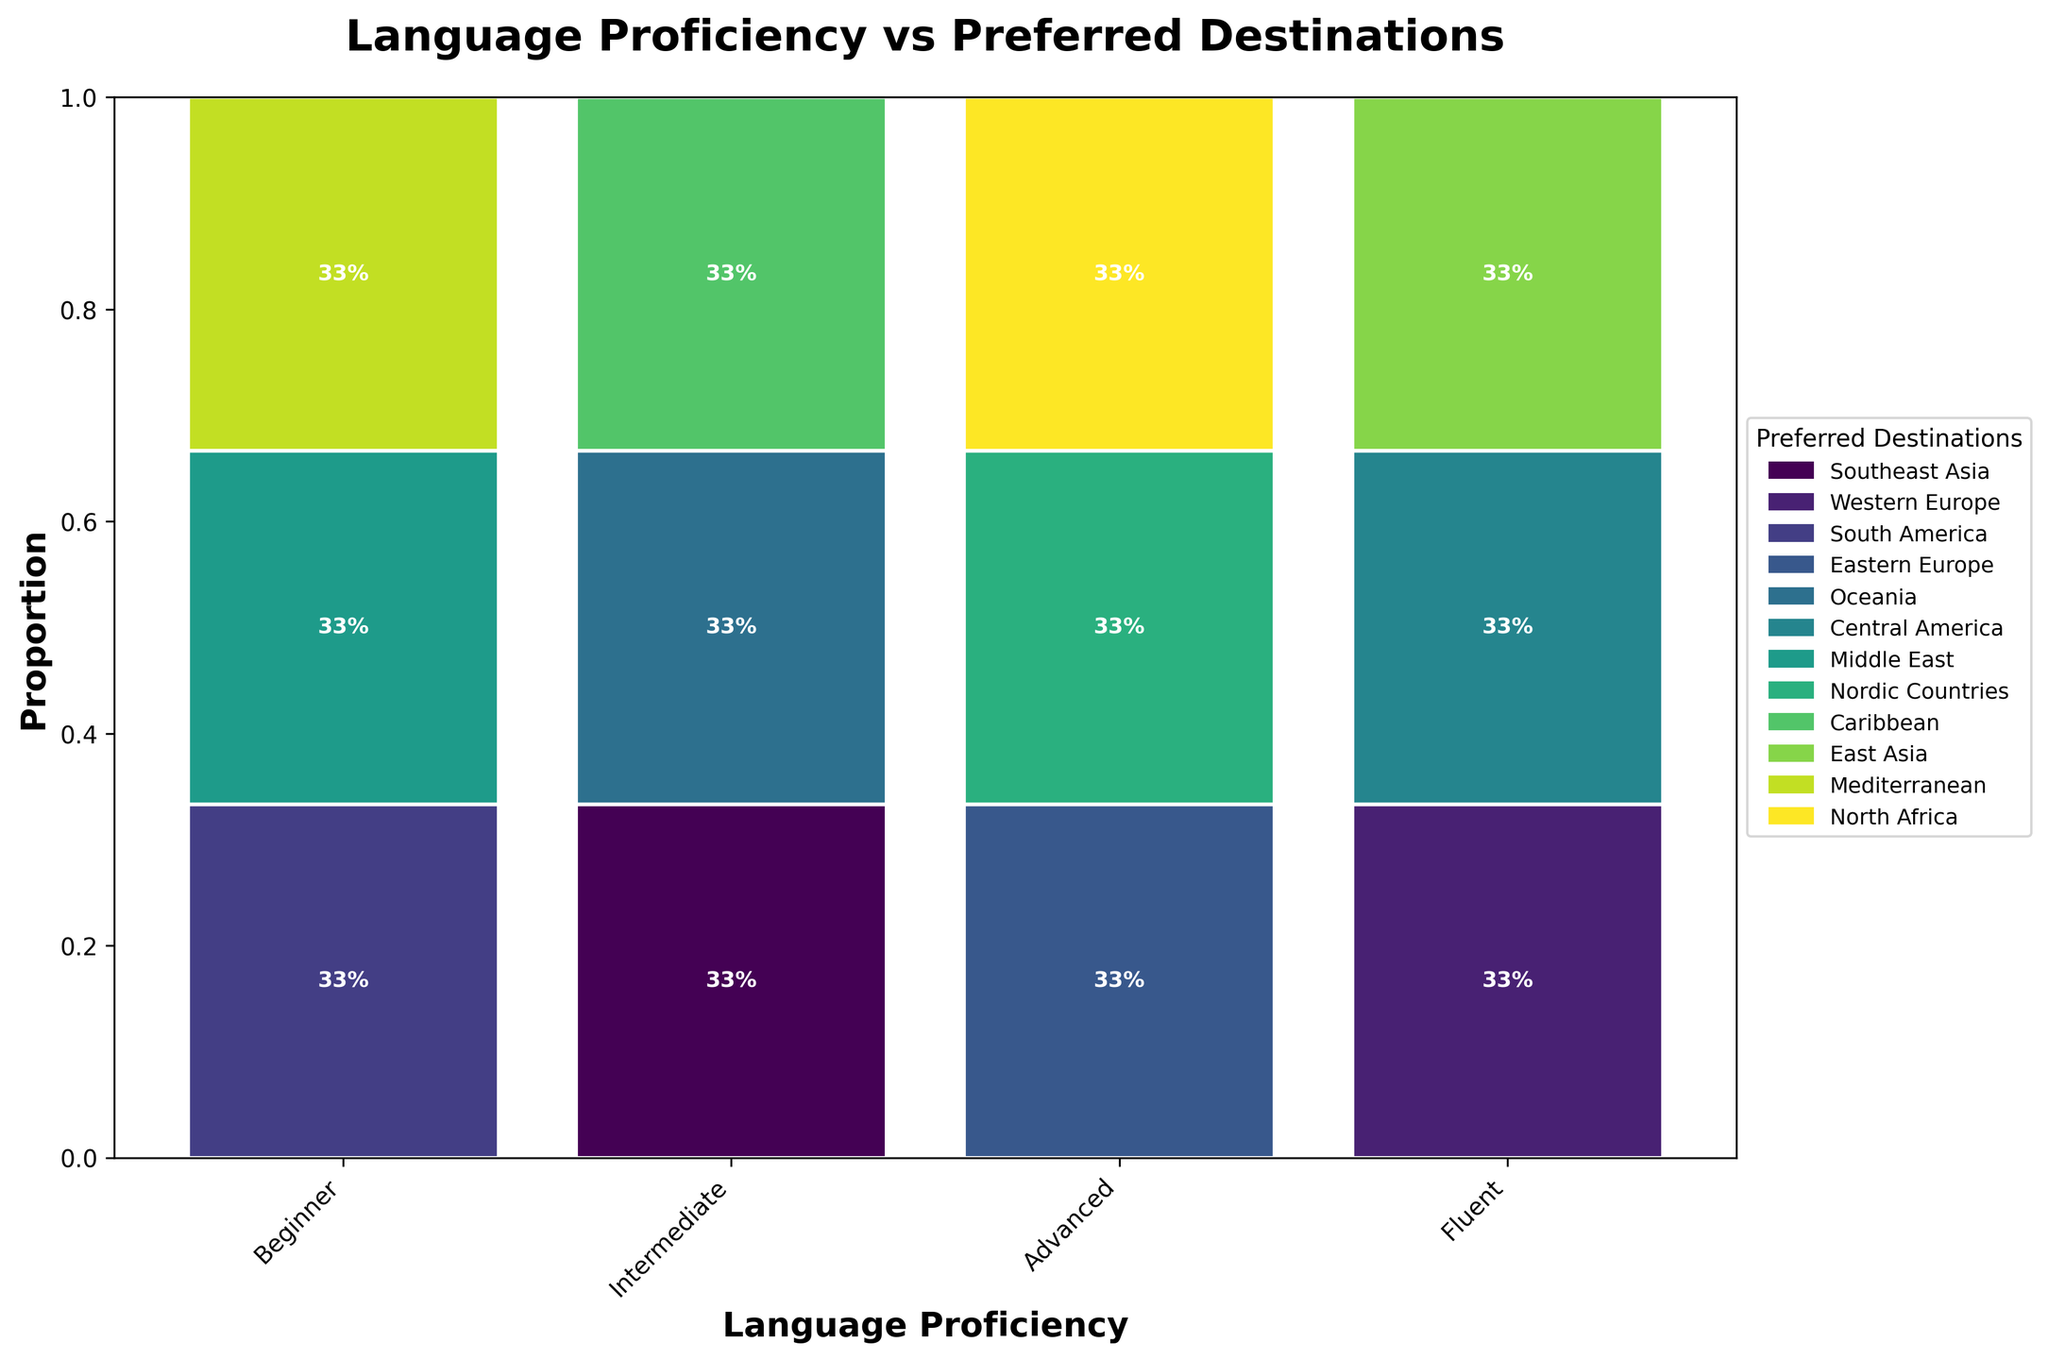What's the title of the plot? The title is usually displayed at the top of the figure in bold or larger font. It provides a summary of what the figure represents.
Answer: Language Proficiency vs Preferred Destinations How many language proficiency levels are shown in the plot? The x-axis represents the different language proficiency levels, and by counting the unique labels along this axis, we can determine the number of levels.
Answer: 4 Which destination has the highest proportion among backpackers with Intermediate proficiency? Look at the bars for Intermediate proficiency and identify which bar segment is the largest. The height represents the proportion.
Answer: Western Europe Which destination has the least proportion among backpackers with Beginner proficiency? Look at the bars for Beginner proficiency and identify which bar segment is the smallest or nearly invisible. The height of the bar indicates the proportion.
Answer: Oceania Are there any destinations with similar proportions for any language proficiency level? Compare the bar heights within the same language proficiency level to see if any segments appear close in size.
Answer: No, all proportions are distinctly different How many travel destinations are represented in this plot? The legend on the right side of the figure lists all the travel destinations with corresponding colors. By counting the legend items, we can determine the number of destinations.
Answer: 12 Compare the proportion of backpackers with Advanced proficiency traveling to South America versus the Mediterranean. Which is higher? Observe the bar segments for Advanced proficiency and compare the heights of South America and the Mediterranean. The taller bar indicates a higher proportion.
Answer: Mediterranean What's the combined proportion of Intermediate-level backpackers traveling to Western Europe and East Asia? Find the proportions for Western Europe and East Asia in the Intermediate category, then add these values together. Western Europe is roughly 0.36 and East Asia is about 0.22. Adding them gives 0.36 + 0.22 = 0.58.
Answer: 58% Which travel destination is the least preferred by backpackers with Fluent proficiency? Check the bar segments for Fluent proficiency and identify the smallest segment by height. This indicates the least preferred destination.
Answer: North Africa How does the proportion of backpackers with Beginner proficiency traveling to Southeast Asia compare to those traveling to the Caribbean? Look at the bar segments for Beginner proficiency and compare the heights for Southeast Asia and the Caribbean. Determine if one is taller or if both are similar.
Answer: Southeast Asia is higher 